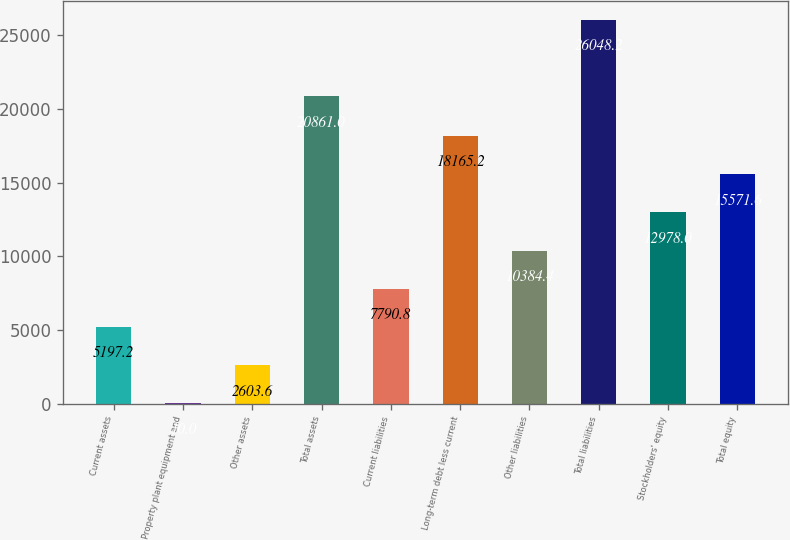Convert chart. <chart><loc_0><loc_0><loc_500><loc_500><bar_chart><fcel>Current assets<fcel>Property plant equipment and<fcel>Other assets<fcel>Total assets<fcel>Current liabilities<fcel>Long-term debt less current<fcel>Other liabilities<fcel>Total liabilities<fcel>Stockholders' equity<fcel>Total equity<nl><fcel>5197.2<fcel>10<fcel>2603.6<fcel>20861<fcel>7790.8<fcel>18165.2<fcel>10384.4<fcel>26048.2<fcel>12978<fcel>15571.6<nl></chart> 